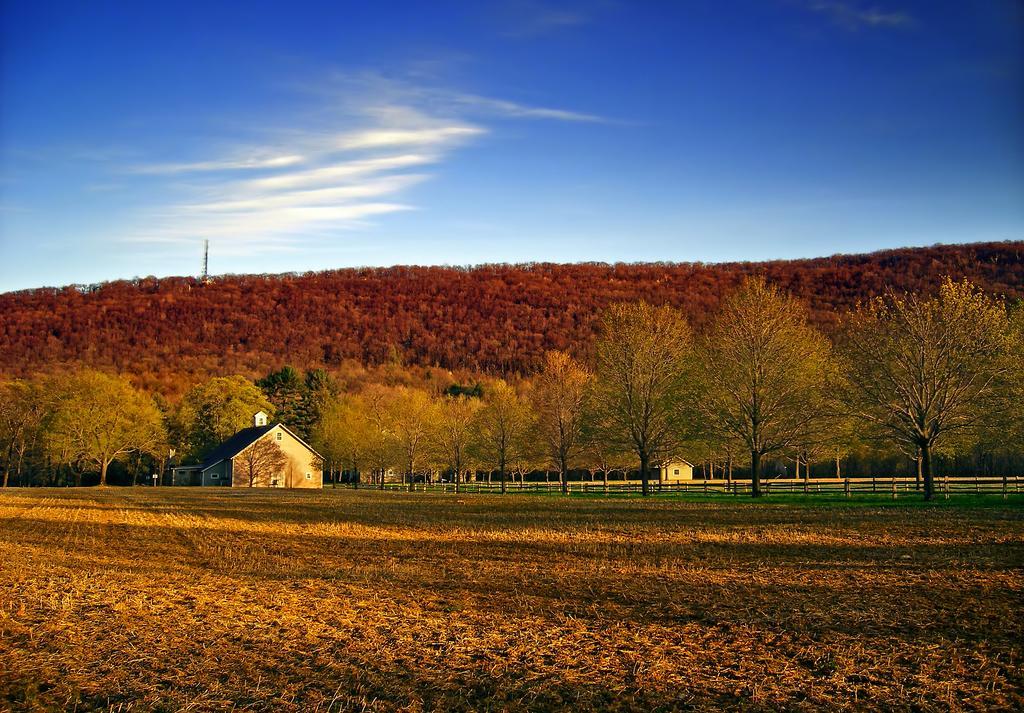How would you summarize this image in a sentence or two? At the bottom of the image we can see grass. In the middle of the image we can see some trees, houses and hill. At the top of the image there are some clouds in the sky. 